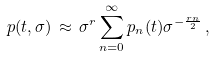<formula> <loc_0><loc_0><loc_500><loc_500>p ( t , \sigma ) \, \approx \, \sigma ^ { r } \sum ^ { \infty } _ { n = 0 } p _ { n } ( t ) \sigma ^ { - \frac { r n } { 2 } } \, ,</formula> 